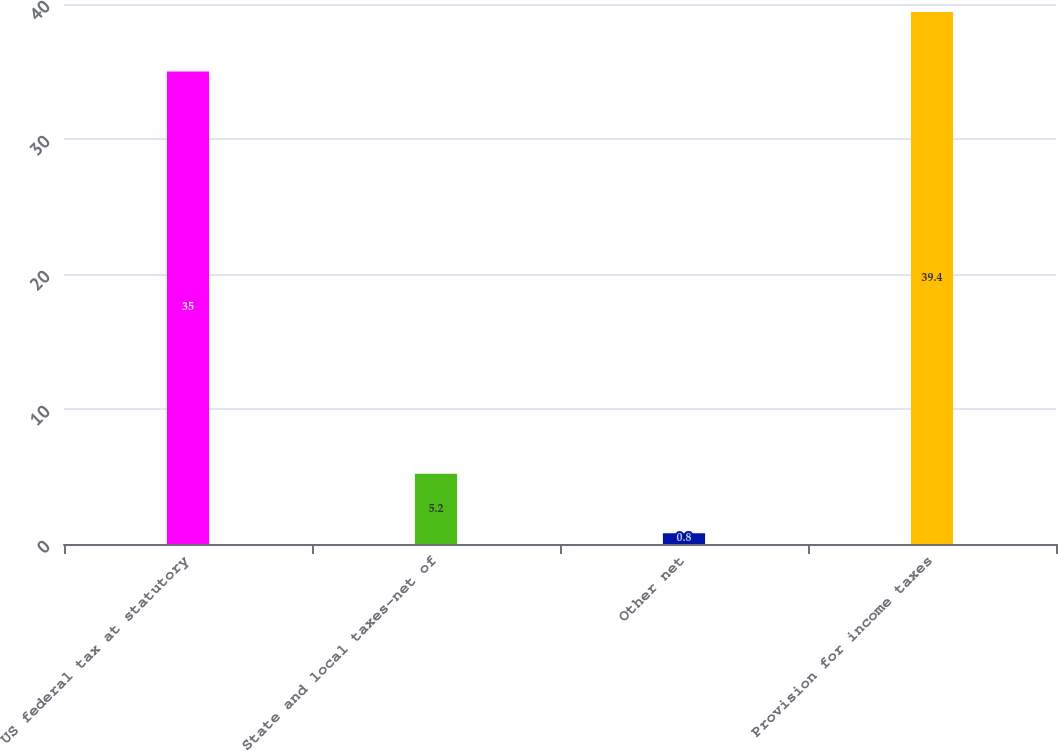<chart> <loc_0><loc_0><loc_500><loc_500><bar_chart><fcel>US federal tax at statutory<fcel>State and local taxes-net of<fcel>Other net<fcel>Provision for income taxes<nl><fcel>35<fcel>5.2<fcel>0.8<fcel>39.4<nl></chart> 